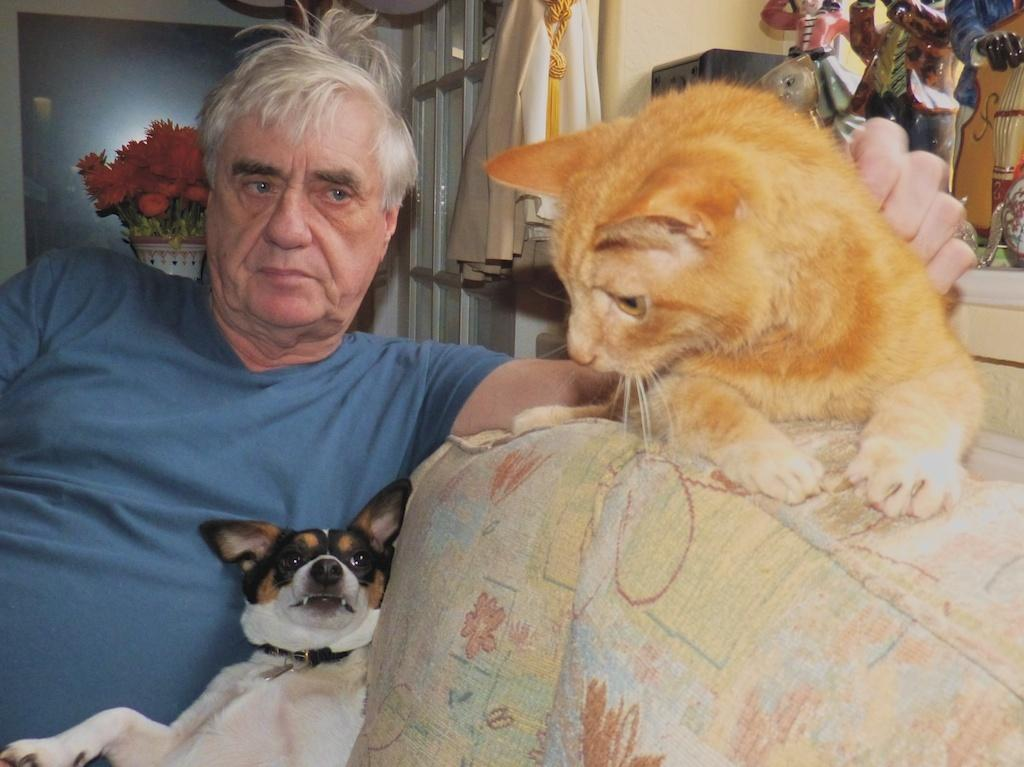What is the man in the image doing? The man is sitting in the image. What animals are present in the image? There is a dog and a cat beside the man. What is behind the man in the image? There is a wall behind the man. Can you describe any other objects in the image? There is a flower pot in the image. What type of agreement is being discussed between the man and the clouds in the image? There are no clouds present in the image, and therefore no discussion about an agreement can be observed. What sound does the cat make in the image? The image is static, and no sounds are audible. 